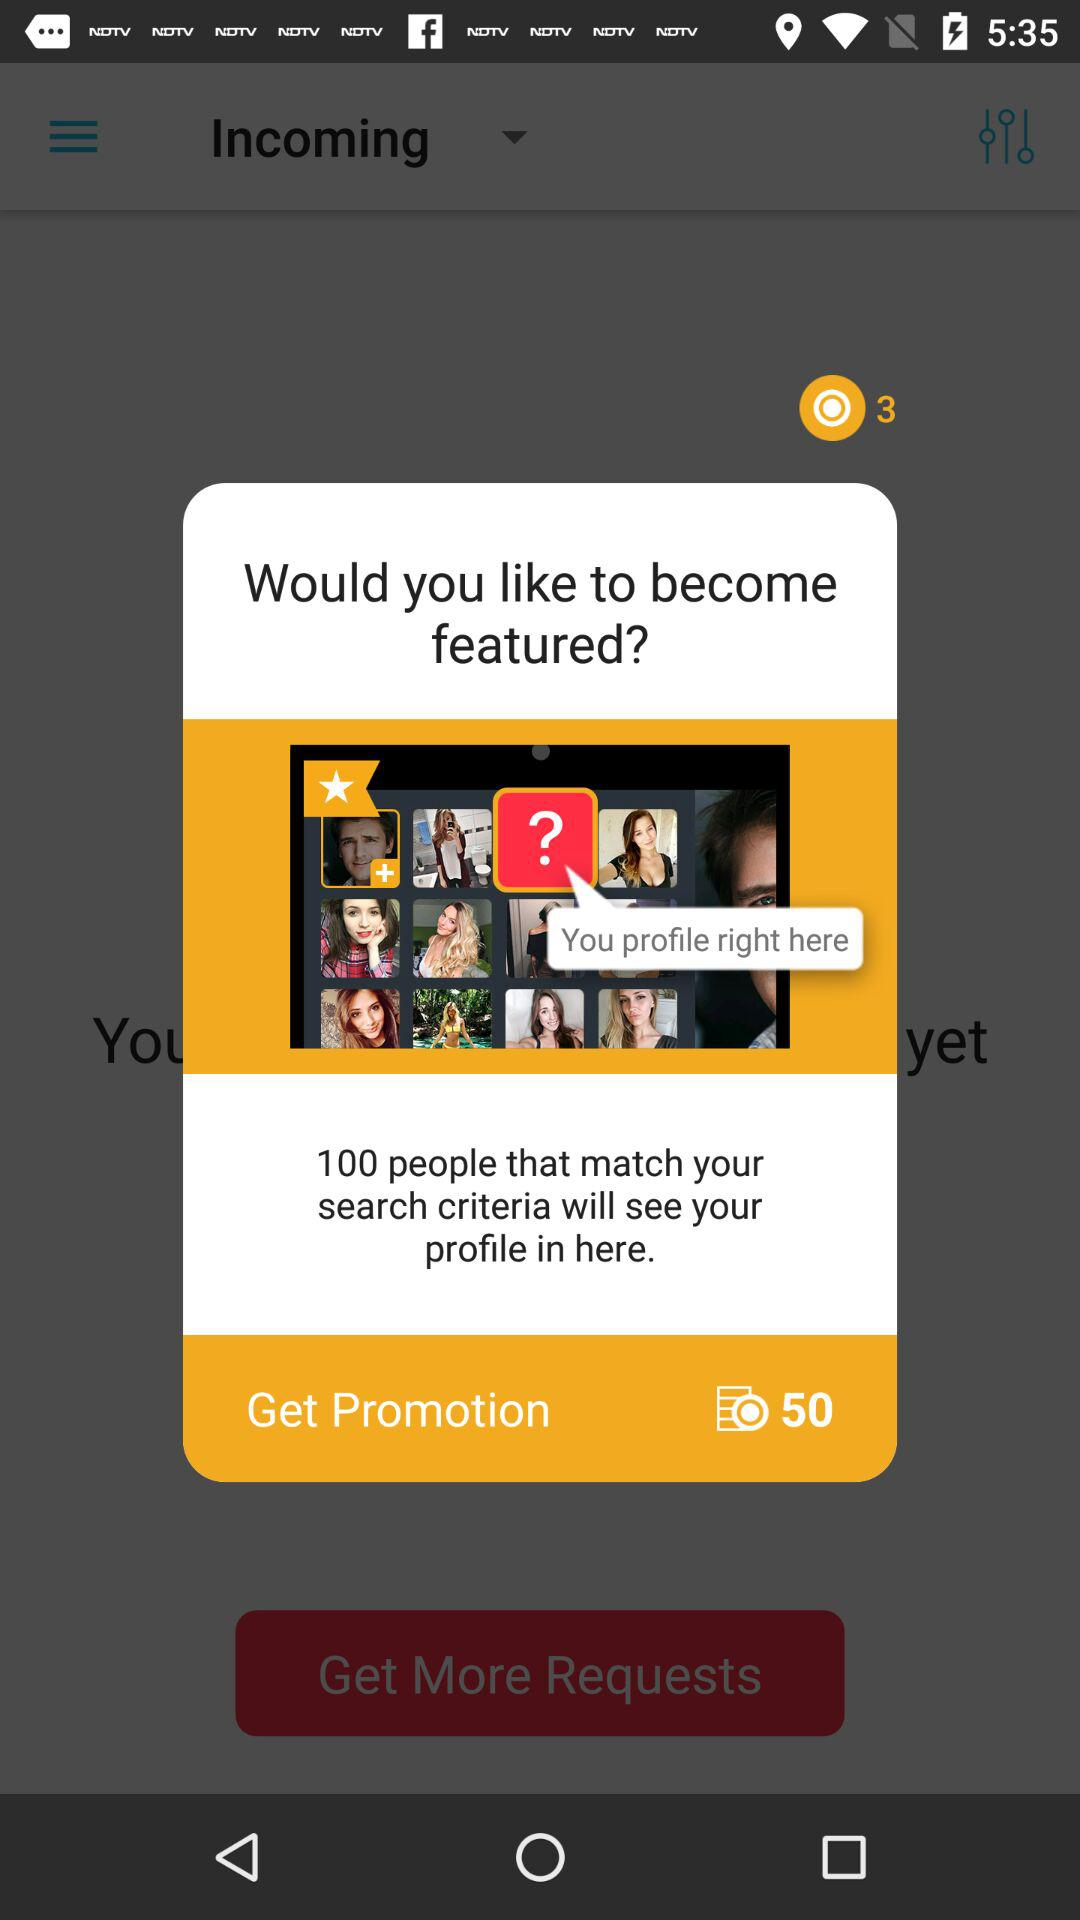How many people will see your profile if you don't get featured?
Answer the question using a single word or phrase. 100 